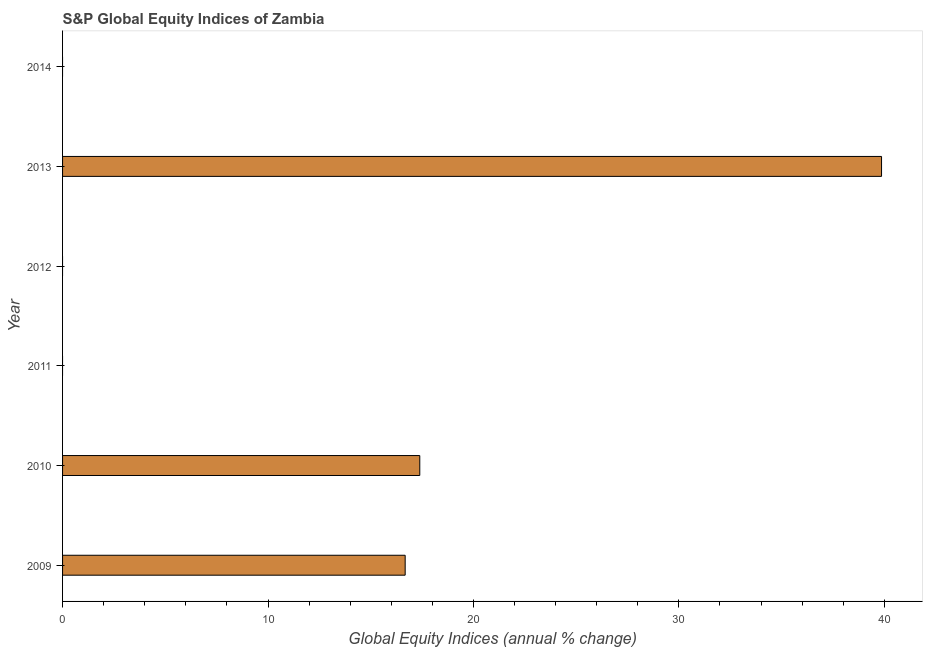Does the graph contain any zero values?
Make the answer very short. Yes. Does the graph contain grids?
Give a very brief answer. No. What is the title of the graph?
Offer a very short reply. S&P Global Equity Indices of Zambia. What is the label or title of the X-axis?
Your response must be concise. Global Equity Indices (annual % change). Across all years, what is the maximum s&p global equity indices?
Offer a very short reply. 39.87. In which year was the s&p global equity indices maximum?
Provide a short and direct response. 2013. What is the sum of the s&p global equity indices?
Offer a terse response. 73.93. What is the difference between the s&p global equity indices in 2010 and 2013?
Your response must be concise. -22.48. What is the average s&p global equity indices per year?
Provide a short and direct response. 12.32. What is the median s&p global equity indices?
Offer a terse response. 8.34. In how many years, is the s&p global equity indices greater than 2 %?
Give a very brief answer. 3. What is the ratio of the s&p global equity indices in 2009 to that in 2010?
Your answer should be compact. 0.96. Is the s&p global equity indices in 2009 less than that in 2013?
Your answer should be very brief. Yes. What is the difference between the highest and the second highest s&p global equity indices?
Ensure brevity in your answer.  22.48. What is the difference between the highest and the lowest s&p global equity indices?
Make the answer very short. 39.87. How many bars are there?
Your answer should be very brief. 3. Are all the bars in the graph horizontal?
Ensure brevity in your answer.  Yes. How many years are there in the graph?
Give a very brief answer. 6. What is the difference between two consecutive major ticks on the X-axis?
Give a very brief answer. 10. Are the values on the major ticks of X-axis written in scientific E-notation?
Provide a short and direct response. No. What is the Global Equity Indices (annual % change) in 2009?
Your response must be concise. 16.68. What is the Global Equity Indices (annual % change) in 2010?
Make the answer very short. 17.39. What is the Global Equity Indices (annual % change) in 2012?
Your answer should be compact. 0. What is the Global Equity Indices (annual % change) in 2013?
Your answer should be very brief. 39.87. What is the Global Equity Indices (annual % change) of 2014?
Your response must be concise. 0. What is the difference between the Global Equity Indices (annual % change) in 2009 and 2010?
Your answer should be compact. -0.71. What is the difference between the Global Equity Indices (annual % change) in 2009 and 2013?
Your answer should be very brief. -23.19. What is the difference between the Global Equity Indices (annual % change) in 2010 and 2013?
Your answer should be compact. -22.48. What is the ratio of the Global Equity Indices (annual % change) in 2009 to that in 2013?
Your response must be concise. 0.42. What is the ratio of the Global Equity Indices (annual % change) in 2010 to that in 2013?
Keep it short and to the point. 0.44. 